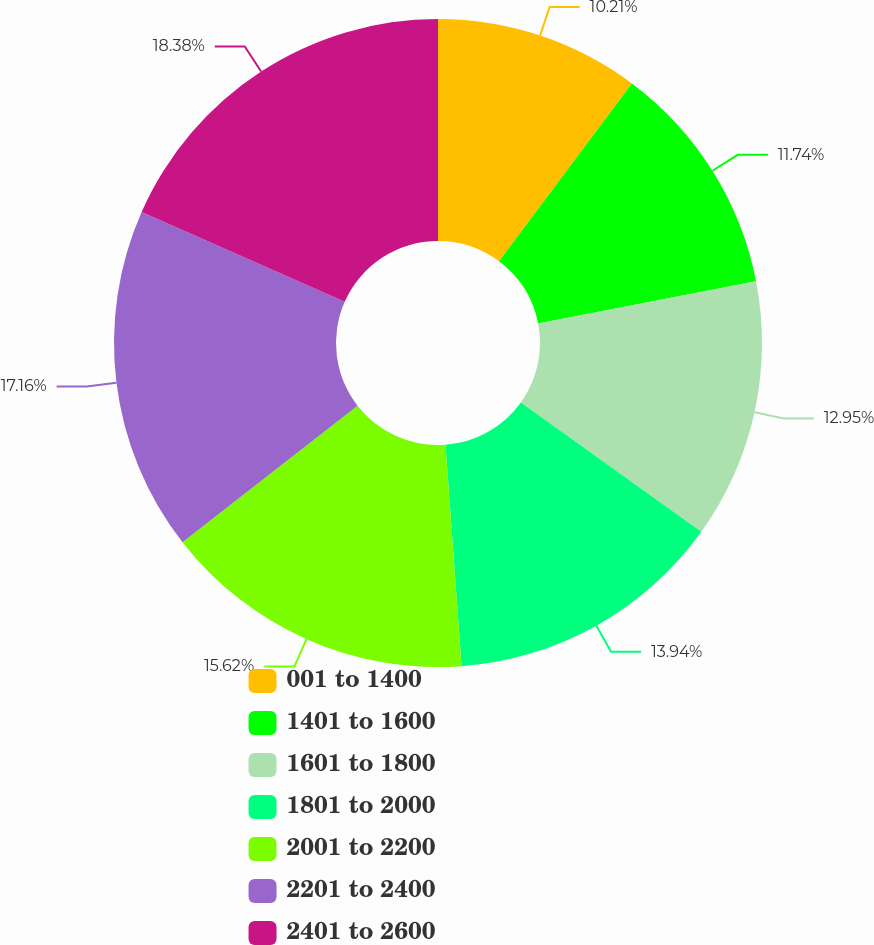Convert chart to OTSL. <chart><loc_0><loc_0><loc_500><loc_500><pie_chart><fcel>001 to 1400<fcel>1401 to 1600<fcel>1601 to 1800<fcel>1801 to 2000<fcel>2001 to 2200<fcel>2201 to 2400<fcel>2401 to 2600<nl><fcel>10.21%<fcel>11.74%<fcel>12.95%<fcel>13.94%<fcel>15.62%<fcel>17.16%<fcel>18.38%<nl></chart> 